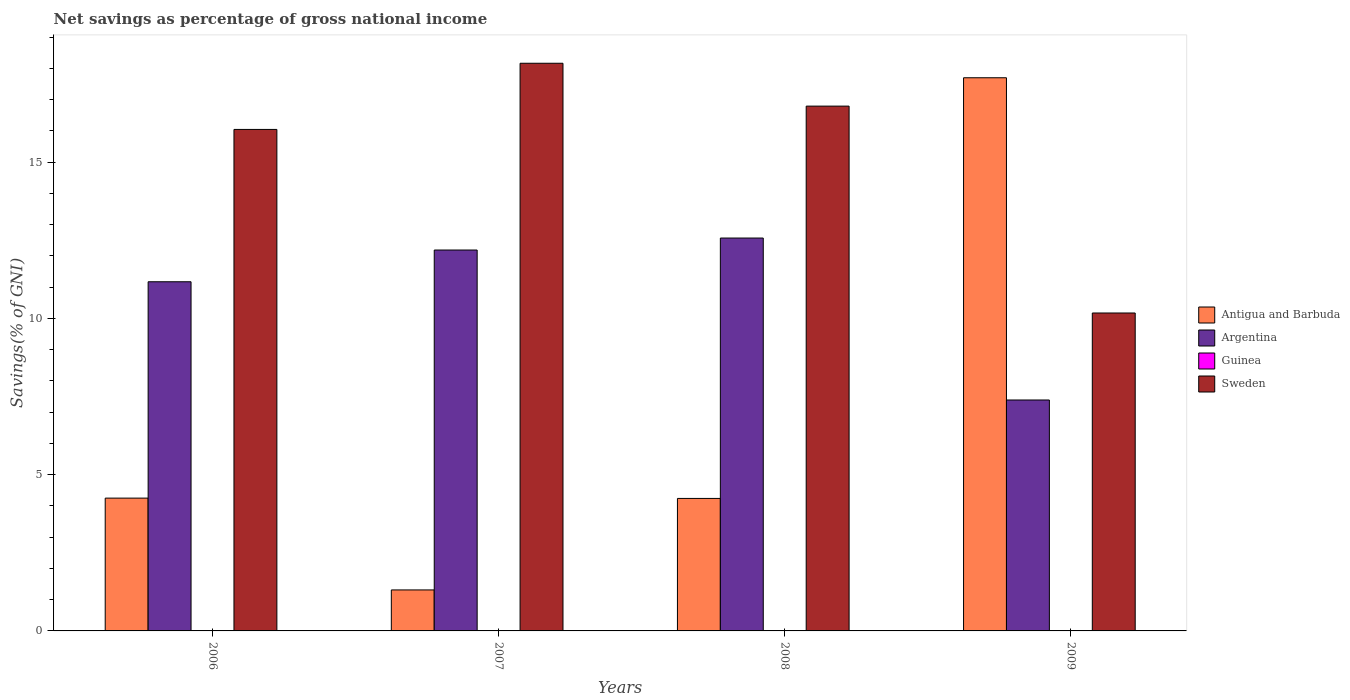Are the number of bars per tick equal to the number of legend labels?
Your answer should be compact. No. How many bars are there on the 1st tick from the left?
Make the answer very short. 3. What is the label of the 3rd group of bars from the left?
Your response must be concise. 2008. What is the total savings in Sweden in 2006?
Your response must be concise. 16.04. Across all years, what is the maximum total savings in Sweden?
Offer a terse response. 18.16. Across all years, what is the minimum total savings in Sweden?
Give a very brief answer. 10.17. What is the total total savings in Sweden in the graph?
Your response must be concise. 61.17. What is the difference between the total savings in Argentina in 2006 and that in 2007?
Your answer should be very brief. -1.02. What is the difference between the total savings in Argentina in 2008 and the total savings in Guinea in 2006?
Provide a short and direct response. 12.57. What is the average total savings in Guinea per year?
Offer a terse response. 0. In the year 2009, what is the difference between the total savings in Antigua and Barbuda and total savings in Argentina?
Your answer should be compact. 10.31. In how many years, is the total savings in Guinea greater than 14 %?
Ensure brevity in your answer.  0. What is the ratio of the total savings in Argentina in 2007 to that in 2009?
Make the answer very short. 1.65. What is the difference between the highest and the second highest total savings in Sweden?
Provide a short and direct response. 1.37. What is the difference between the highest and the lowest total savings in Argentina?
Your answer should be compact. 5.18. In how many years, is the total savings in Argentina greater than the average total savings in Argentina taken over all years?
Your response must be concise. 3. Is the sum of the total savings in Sweden in 2006 and 2007 greater than the maximum total savings in Argentina across all years?
Give a very brief answer. Yes. Is it the case that in every year, the sum of the total savings in Guinea and total savings in Argentina is greater than the total savings in Antigua and Barbuda?
Your answer should be compact. No. How many bars are there?
Offer a very short reply. 12. Are all the bars in the graph horizontal?
Your response must be concise. No. How many years are there in the graph?
Offer a very short reply. 4. Where does the legend appear in the graph?
Provide a succinct answer. Center right. How many legend labels are there?
Provide a short and direct response. 4. What is the title of the graph?
Make the answer very short. Net savings as percentage of gross national income. Does "Samoa" appear as one of the legend labels in the graph?
Your answer should be compact. No. What is the label or title of the X-axis?
Offer a very short reply. Years. What is the label or title of the Y-axis?
Keep it short and to the point. Savings(% of GNI). What is the Savings(% of GNI) of Antigua and Barbuda in 2006?
Provide a succinct answer. 4.25. What is the Savings(% of GNI) of Argentina in 2006?
Provide a succinct answer. 11.17. What is the Savings(% of GNI) in Sweden in 2006?
Your response must be concise. 16.04. What is the Savings(% of GNI) in Antigua and Barbuda in 2007?
Offer a very short reply. 1.31. What is the Savings(% of GNI) of Argentina in 2007?
Offer a terse response. 12.19. What is the Savings(% of GNI) of Guinea in 2007?
Provide a succinct answer. 0. What is the Savings(% of GNI) of Sweden in 2007?
Provide a short and direct response. 18.16. What is the Savings(% of GNI) in Antigua and Barbuda in 2008?
Ensure brevity in your answer.  4.24. What is the Savings(% of GNI) of Argentina in 2008?
Your response must be concise. 12.57. What is the Savings(% of GNI) in Sweden in 2008?
Your answer should be compact. 16.79. What is the Savings(% of GNI) of Antigua and Barbuda in 2009?
Make the answer very short. 17.7. What is the Savings(% of GNI) in Argentina in 2009?
Your answer should be compact. 7.39. What is the Savings(% of GNI) in Guinea in 2009?
Make the answer very short. 0. What is the Savings(% of GNI) of Sweden in 2009?
Give a very brief answer. 10.17. Across all years, what is the maximum Savings(% of GNI) of Antigua and Barbuda?
Offer a terse response. 17.7. Across all years, what is the maximum Savings(% of GNI) in Argentina?
Provide a succinct answer. 12.57. Across all years, what is the maximum Savings(% of GNI) in Sweden?
Your answer should be very brief. 18.16. Across all years, what is the minimum Savings(% of GNI) of Antigua and Barbuda?
Provide a succinct answer. 1.31. Across all years, what is the minimum Savings(% of GNI) of Argentina?
Your response must be concise. 7.39. Across all years, what is the minimum Savings(% of GNI) in Sweden?
Keep it short and to the point. 10.17. What is the total Savings(% of GNI) in Antigua and Barbuda in the graph?
Offer a very short reply. 27.5. What is the total Savings(% of GNI) in Argentina in the graph?
Offer a very short reply. 43.32. What is the total Savings(% of GNI) in Sweden in the graph?
Offer a terse response. 61.17. What is the difference between the Savings(% of GNI) of Antigua and Barbuda in 2006 and that in 2007?
Offer a very short reply. 2.94. What is the difference between the Savings(% of GNI) in Argentina in 2006 and that in 2007?
Ensure brevity in your answer.  -1.02. What is the difference between the Savings(% of GNI) of Sweden in 2006 and that in 2007?
Give a very brief answer. -2.12. What is the difference between the Savings(% of GNI) in Antigua and Barbuda in 2006 and that in 2008?
Your response must be concise. 0.01. What is the difference between the Savings(% of GNI) of Argentina in 2006 and that in 2008?
Offer a very short reply. -1.4. What is the difference between the Savings(% of GNI) of Sweden in 2006 and that in 2008?
Give a very brief answer. -0.75. What is the difference between the Savings(% of GNI) in Antigua and Barbuda in 2006 and that in 2009?
Provide a short and direct response. -13.45. What is the difference between the Savings(% of GNI) in Argentina in 2006 and that in 2009?
Your answer should be very brief. 3.78. What is the difference between the Savings(% of GNI) of Sweden in 2006 and that in 2009?
Your answer should be compact. 5.87. What is the difference between the Savings(% of GNI) in Antigua and Barbuda in 2007 and that in 2008?
Your response must be concise. -2.93. What is the difference between the Savings(% of GNI) in Argentina in 2007 and that in 2008?
Your response must be concise. -0.38. What is the difference between the Savings(% of GNI) of Sweden in 2007 and that in 2008?
Make the answer very short. 1.37. What is the difference between the Savings(% of GNI) of Antigua and Barbuda in 2007 and that in 2009?
Provide a short and direct response. -16.39. What is the difference between the Savings(% of GNI) of Argentina in 2007 and that in 2009?
Your response must be concise. 4.8. What is the difference between the Savings(% of GNI) of Sweden in 2007 and that in 2009?
Your response must be concise. 7.99. What is the difference between the Savings(% of GNI) in Antigua and Barbuda in 2008 and that in 2009?
Your answer should be compact. -13.46. What is the difference between the Savings(% of GNI) in Argentina in 2008 and that in 2009?
Keep it short and to the point. 5.18. What is the difference between the Savings(% of GNI) in Sweden in 2008 and that in 2009?
Provide a succinct answer. 6.62. What is the difference between the Savings(% of GNI) of Antigua and Barbuda in 2006 and the Savings(% of GNI) of Argentina in 2007?
Offer a terse response. -7.94. What is the difference between the Savings(% of GNI) in Antigua and Barbuda in 2006 and the Savings(% of GNI) in Sweden in 2007?
Your answer should be compact. -13.91. What is the difference between the Savings(% of GNI) in Argentina in 2006 and the Savings(% of GNI) in Sweden in 2007?
Your response must be concise. -6.99. What is the difference between the Savings(% of GNI) in Antigua and Barbuda in 2006 and the Savings(% of GNI) in Argentina in 2008?
Provide a short and direct response. -8.32. What is the difference between the Savings(% of GNI) in Antigua and Barbuda in 2006 and the Savings(% of GNI) in Sweden in 2008?
Your response must be concise. -12.54. What is the difference between the Savings(% of GNI) of Argentina in 2006 and the Savings(% of GNI) of Sweden in 2008?
Your answer should be compact. -5.62. What is the difference between the Savings(% of GNI) in Antigua and Barbuda in 2006 and the Savings(% of GNI) in Argentina in 2009?
Make the answer very short. -3.14. What is the difference between the Savings(% of GNI) of Antigua and Barbuda in 2006 and the Savings(% of GNI) of Sweden in 2009?
Ensure brevity in your answer.  -5.92. What is the difference between the Savings(% of GNI) in Antigua and Barbuda in 2007 and the Savings(% of GNI) in Argentina in 2008?
Offer a very short reply. -11.26. What is the difference between the Savings(% of GNI) of Antigua and Barbuda in 2007 and the Savings(% of GNI) of Sweden in 2008?
Your response must be concise. -15.48. What is the difference between the Savings(% of GNI) in Argentina in 2007 and the Savings(% of GNI) in Sweden in 2008?
Ensure brevity in your answer.  -4.6. What is the difference between the Savings(% of GNI) in Antigua and Barbuda in 2007 and the Savings(% of GNI) in Argentina in 2009?
Make the answer very short. -6.08. What is the difference between the Savings(% of GNI) of Antigua and Barbuda in 2007 and the Savings(% of GNI) of Sweden in 2009?
Offer a very short reply. -8.86. What is the difference between the Savings(% of GNI) of Argentina in 2007 and the Savings(% of GNI) of Sweden in 2009?
Your answer should be very brief. 2.01. What is the difference between the Savings(% of GNI) of Antigua and Barbuda in 2008 and the Savings(% of GNI) of Argentina in 2009?
Your response must be concise. -3.15. What is the difference between the Savings(% of GNI) of Antigua and Barbuda in 2008 and the Savings(% of GNI) of Sweden in 2009?
Your answer should be compact. -5.93. What is the difference between the Savings(% of GNI) of Argentina in 2008 and the Savings(% of GNI) of Sweden in 2009?
Make the answer very short. 2.4. What is the average Savings(% of GNI) in Antigua and Barbuda per year?
Your answer should be compact. 6.87. What is the average Savings(% of GNI) in Argentina per year?
Give a very brief answer. 10.83. What is the average Savings(% of GNI) of Sweden per year?
Provide a succinct answer. 15.29. In the year 2006, what is the difference between the Savings(% of GNI) of Antigua and Barbuda and Savings(% of GNI) of Argentina?
Offer a terse response. -6.92. In the year 2006, what is the difference between the Savings(% of GNI) in Antigua and Barbuda and Savings(% of GNI) in Sweden?
Your response must be concise. -11.8. In the year 2006, what is the difference between the Savings(% of GNI) in Argentina and Savings(% of GNI) in Sweden?
Offer a very short reply. -4.87. In the year 2007, what is the difference between the Savings(% of GNI) in Antigua and Barbuda and Savings(% of GNI) in Argentina?
Provide a succinct answer. -10.88. In the year 2007, what is the difference between the Savings(% of GNI) in Antigua and Barbuda and Savings(% of GNI) in Sweden?
Provide a succinct answer. -16.85. In the year 2007, what is the difference between the Savings(% of GNI) in Argentina and Savings(% of GNI) in Sweden?
Make the answer very short. -5.98. In the year 2008, what is the difference between the Savings(% of GNI) in Antigua and Barbuda and Savings(% of GNI) in Argentina?
Provide a short and direct response. -8.33. In the year 2008, what is the difference between the Savings(% of GNI) of Antigua and Barbuda and Savings(% of GNI) of Sweden?
Offer a terse response. -12.55. In the year 2008, what is the difference between the Savings(% of GNI) of Argentina and Savings(% of GNI) of Sweden?
Offer a terse response. -4.22. In the year 2009, what is the difference between the Savings(% of GNI) of Antigua and Barbuda and Savings(% of GNI) of Argentina?
Give a very brief answer. 10.31. In the year 2009, what is the difference between the Savings(% of GNI) in Antigua and Barbuda and Savings(% of GNI) in Sweden?
Your answer should be very brief. 7.53. In the year 2009, what is the difference between the Savings(% of GNI) in Argentina and Savings(% of GNI) in Sweden?
Make the answer very short. -2.78. What is the ratio of the Savings(% of GNI) of Antigua and Barbuda in 2006 to that in 2007?
Offer a very short reply. 3.24. What is the ratio of the Savings(% of GNI) in Sweden in 2006 to that in 2007?
Provide a succinct answer. 0.88. What is the ratio of the Savings(% of GNI) of Argentina in 2006 to that in 2008?
Ensure brevity in your answer.  0.89. What is the ratio of the Savings(% of GNI) of Sweden in 2006 to that in 2008?
Your answer should be very brief. 0.96. What is the ratio of the Savings(% of GNI) in Antigua and Barbuda in 2006 to that in 2009?
Offer a terse response. 0.24. What is the ratio of the Savings(% of GNI) in Argentina in 2006 to that in 2009?
Keep it short and to the point. 1.51. What is the ratio of the Savings(% of GNI) of Sweden in 2006 to that in 2009?
Provide a short and direct response. 1.58. What is the ratio of the Savings(% of GNI) in Antigua and Barbuda in 2007 to that in 2008?
Your answer should be very brief. 0.31. What is the ratio of the Savings(% of GNI) in Argentina in 2007 to that in 2008?
Your answer should be compact. 0.97. What is the ratio of the Savings(% of GNI) of Sweden in 2007 to that in 2008?
Give a very brief answer. 1.08. What is the ratio of the Savings(% of GNI) in Antigua and Barbuda in 2007 to that in 2009?
Keep it short and to the point. 0.07. What is the ratio of the Savings(% of GNI) in Argentina in 2007 to that in 2009?
Provide a short and direct response. 1.65. What is the ratio of the Savings(% of GNI) in Sweden in 2007 to that in 2009?
Your response must be concise. 1.79. What is the ratio of the Savings(% of GNI) of Antigua and Barbuda in 2008 to that in 2009?
Your answer should be very brief. 0.24. What is the ratio of the Savings(% of GNI) of Argentina in 2008 to that in 2009?
Keep it short and to the point. 1.7. What is the ratio of the Savings(% of GNI) in Sweden in 2008 to that in 2009?
Give a very brief answer. 1.65. What is the difference between the highest and the second highest Savings(% of GNI) in Antigua and Barbuda?
Provide a succinct answer. 13.45. What is the difference between the highest and the second highest Savings(% of GNI) in Argentina?
Ensure brevity in your answer.  0.38. What is the difference between the highest and the second highest Savings(% of GNI) of Sweden?
Offer a very short reply. 1.37. What is the difference between the highest and the lowest Savings(% of GNI) of Antigua and Barbuda?
Make the answer very short. 16.39. What is the difference between the highest and the lowest Savings(% of GNI) of Argentina?
Ensure brevity in your answer.  5.18. What is the difference between the highest and the lowest Savings(% of GNI) of Sweden?
Make the answer very short. 7.99. 